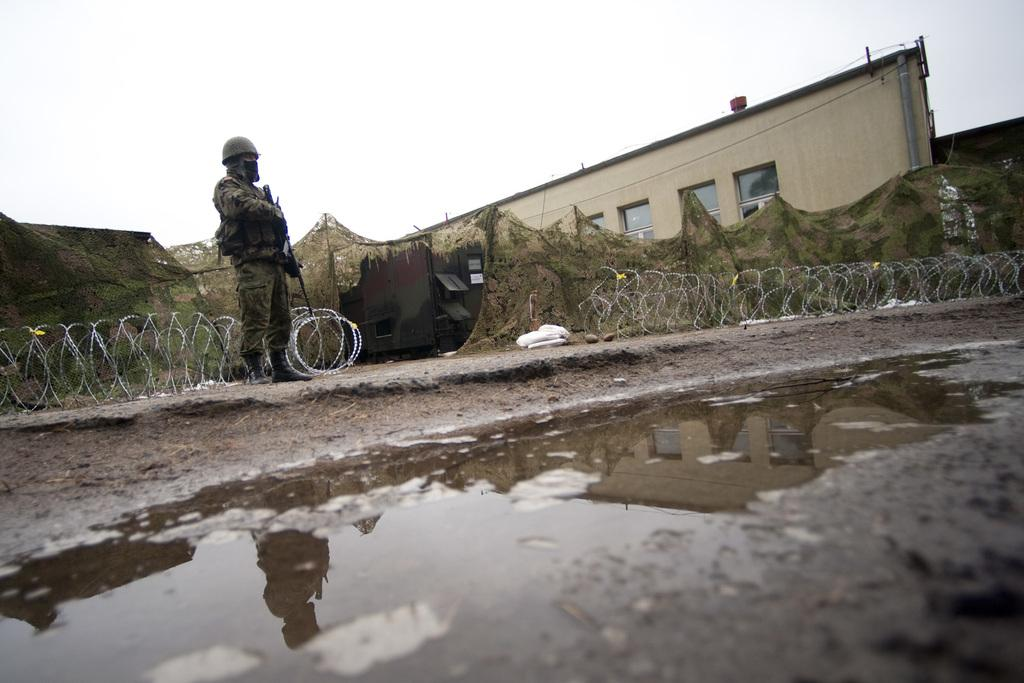Who or what is present in the image? There is a person in the image. What is the primary element visible in the image? Water is visible in the image. What type of surface can be seen in the image? Ground is visible in the image. What type of shelter is present in the image? There is a tent in the image. What type of barrier is present in the image? There is a fence in the image. What type of structure is present in the image? There is a building in the image. What is visible in the background of the image? The sky is visible in the background of the image. What shape is the door in the image? There is no door present in the image. 